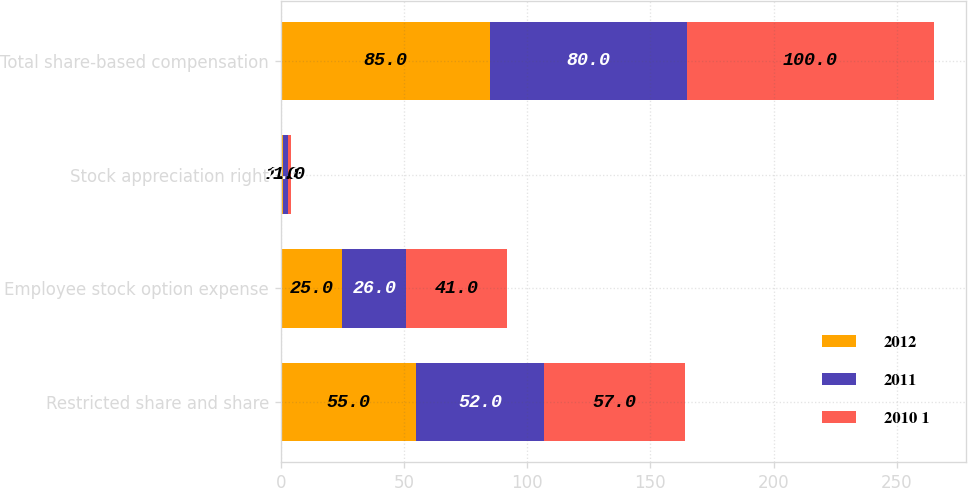Convert chart. <chart><loc_0><loc_0><loc_500><loc_500><stacked_bar_chart><ecel><fcel>Restricted share and share<fcel>Employee stock option expense<fcel>Stock appreciation right<fcel>Total share-based compensation<nl><fcel>2012<fcel>55<fcel>25<fcel>1<fcel>85<nl><fcel>2011<fcel>52<fcel>26<fcel>2<fcel>80<nl><fcel>2010 1<fcel>57<fcel>41<fcel>1<fcel>100<nl></chart> 